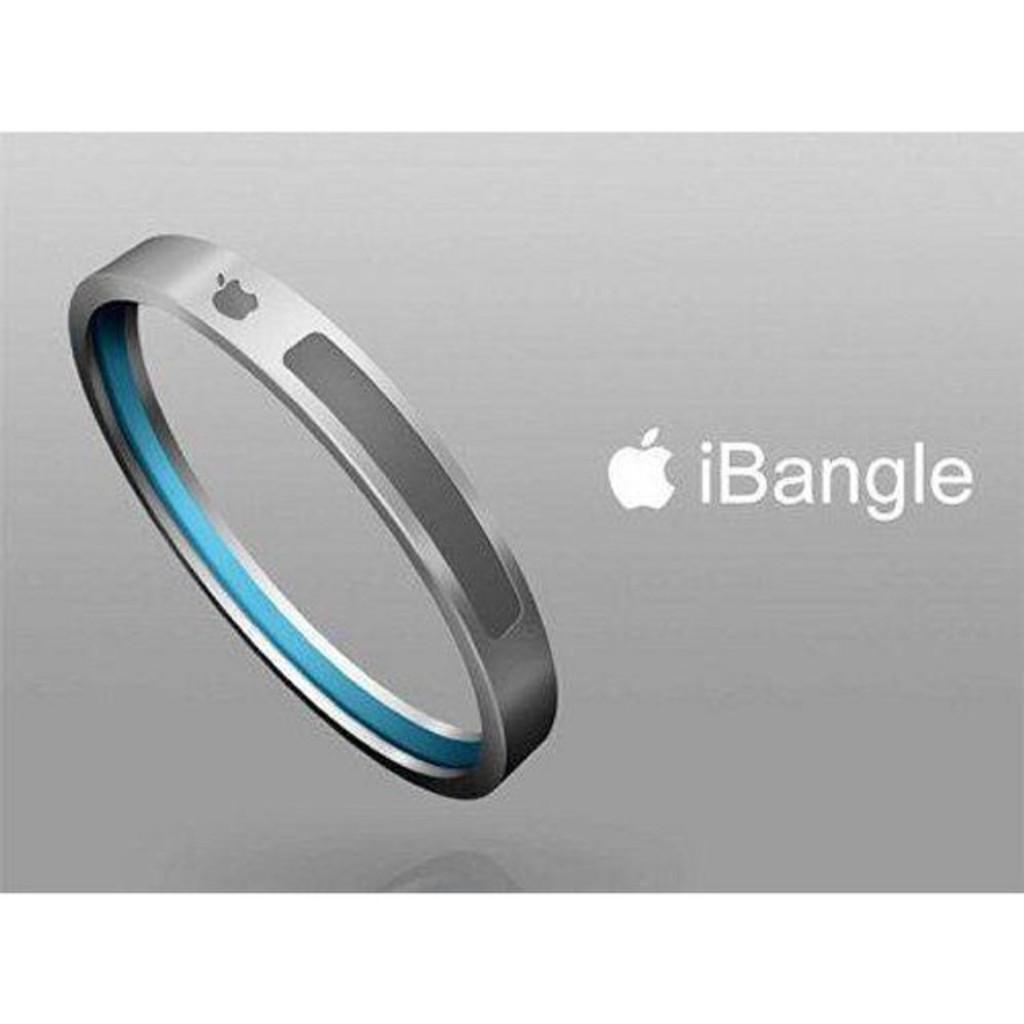Provide a one-sentence caption for the provided image. An Apple product that is designed to be worn on the wrist. 